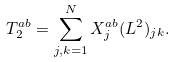<formula> <loc_0><loc_0><loc_500><loc_500>T _ { 2 } ^ { a b } = \sum _ { j , k = 1 } ^ { N } X _ { j } ^ { a b } ( L ^ { 2 } ) _ { j k } .</formula> 